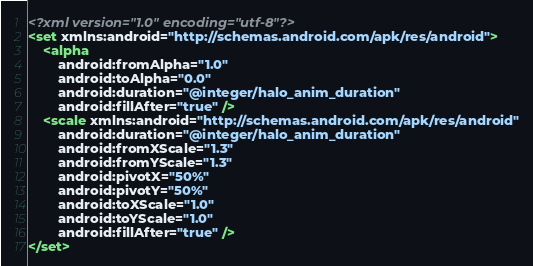Convert code to text. <code><loc_0><loc_0><loc_500><loc_500><_XML_><?xml version="1.0" encoding="utf-8"?>
<set xmlns:android="http://schemas.android.com/apk/res/android">
    <alpha
        android:fromAlpha="1.0"
        android:toAlpha="0.0"
        android:duration="@integer/halo_anim_duration"
        android:fillAfter="true" />
    <scale xmlns:android="http://schemas.android.com/apk/res/android"
        android:duration="@integer/halo_anim_duration"
        android:fromXScale="1.3"
        android:fromYScale="1.3"
        android:pivotX="50%"
        android:pivotY="50%"
        android:toXScale="1.0"
        android:toYScale="1.0"
        android:fillAfter="true" />
</set></code> 